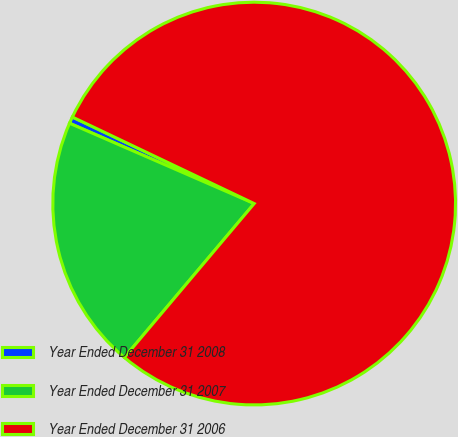Convert chart. <chart><loc_0><loc_0><loc_500><loc_500><pie_chart><fcel>Year Ended December 31 2008<fcel>Year Ended December 31 2007<fcel>Year Ended December 31 2006<nl><fcel>0.54%<fcel>20.38%<fcel>79.08%<nl></chart> 